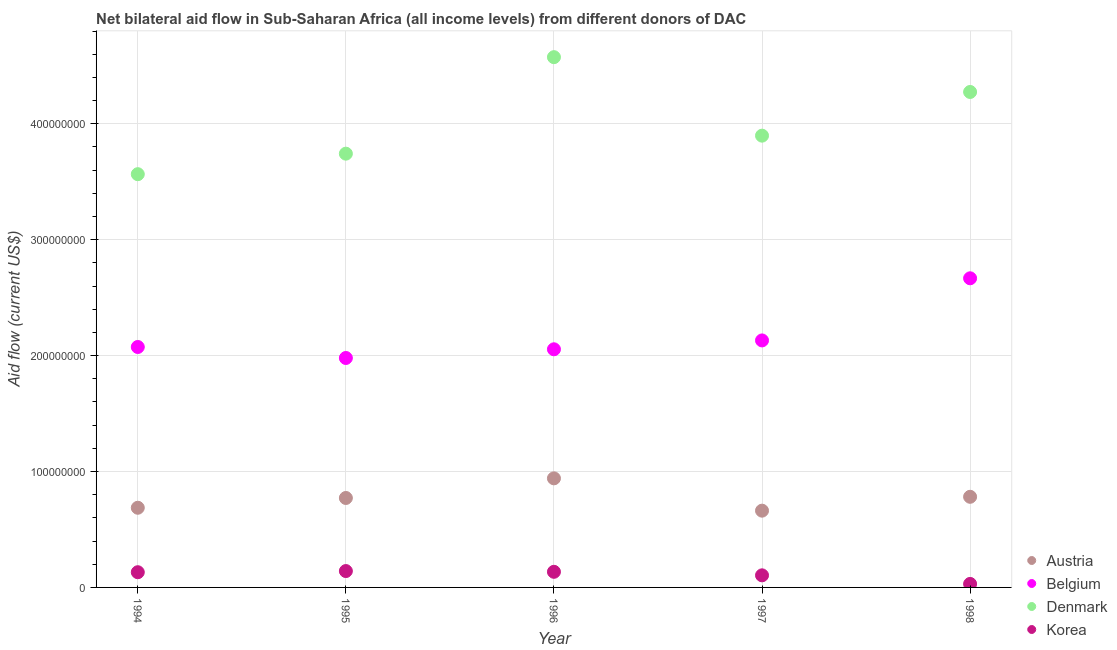How many different coloured dotlines are there?
Provide a short and direct response. 4. What is the amount of aid given by korea in 1998?
Your response must be concise. 3.02e+06. Across all years, what is the maximum amount of aid given by austria?
Ensure brevity in your answer.  9.41e+07. Across all years, what is the minimum amount of aid given by austria?
Keep it short and to the point. 6.62e+07. What is the total amount of aid given by belgium in the graph?
Give a very brief answer. 1.09e+09. What is the difference between the amount of aid given by korea in 1995 and that in 1996?
Your answer should be compact. 6.50e+05. What is the difference between the amount of aid given by denmark in 1997 and the amount of aid given by austria in 1998?
Offer a terse response. 3.12e+08. What is the average amount of aid given by belgium per year?
Give a very brief answer. 2.18e+08. In the year 1994, what is the difference between the amount of aid given by belgium and amount of aid given by austria?
Your answer should be compact. 1.39e+08. In how many years, is the amount of aid given by belgium greater than 460000000 US$?
Your response must be concise. 0. What is the ratio of the amount of aid given by austria in 1996 to that in 1998?
Give a very brief answer. 1.2. Is the difference between the amount of aid given by denmark in 1994 and 1995 greater than the difference between the amount of aid given by belgium in 1994 and 1995?
Provide a succinct answer. No. What is the difference between the highest and the second highest amount of aid given by korea?
Keep it short and to the point. 6.50e+05. What is the difference between the highest and the lowest amount of aid given by korea?
Provide a succinct answer. 1.11e+07. Is the sum of the amount of aid given by austria in 1995 and 1997 greater than the maximum amount of aid given by denmark across all years?
Offer a very short reply. No. Is it the case that in every year, the sum of the amount of aid given by denmark and amount of aid given by korea is greater than the sum of amount of aid given by belgium and amount of aid given by austria?
Your response must be concise. No. Is the amount of aid given by austria strictly greater than the amount of aid given by denmark over the years?
Make the answer very short. No. Is the amount of aid given by belgium strictly less than the amount of aid given by denmark over the years?
Offer a very short reply. Yes. How many dotlines are there?
Your response must be concise. 4. Are the values on the major ticks of Y-axis written in scientific E-notation?
Your answer should be very brief. No. Does the graph contain any zero values?
Give a very brief answer. No. Does the graph contain grids?
Your response must be concise. Yes. What is the title of the graph?
Your answer should be compact. Net bilateral aid flow in Sub-Saharan Africa (all income levels) from different donors of DAC. What is the label or title of the X-axis?
Make the answer very short. Year. What is the Aid flow (current US$) in Austria in 1994?
Provide a short and direct response. 6.87e+07. What is the Aid flow (current US$) in Belgium in 1994?
Offer a very short reply. 2.07e+08. What is the Aid flow (current US$) in Denmark in 1994?
Provide a succinct answer. 3.56e+08. What is the Aid flow (current US$) in Korea in 1994?
Offer a terse response. 1.31e+07. What is the Aid flow (current US$) in Austria in 1995?
Keep it short and to the point. 7.72e+07. What is the Aid flow (current US$) of Belgium in 1995?
Make the answer very short. 1.98e+08. What is the Aid flow (current US$) of Denmark in 1995?
Ensure brevity in your answer.  3.74e+08. What is the Aid flow (current US$) in Korea in 1995?
Give a very brief answer. 1.41e+07. What is the Aid flow (current US$) of Austria in 1996?
Offer a terse response. 9.41e+07. What is the Aid flow (current US$) in Belgium in 1996?
Offer a very short reply. 2.05e+08. What is the Aid flow (current US$) of Denmark in 1996?
Provide a succinct answer. 4.57e+08. What is the Aid flow (current US$) of Korea in 1996?
Make the answer very short. 1.35e+07. What is the Aid flow (current US$) of Austria in 1997?
Your response must be concise. 6.62e+07. What is the Aid flow (current US$) of Belgium in 1997?
Your response must be concise. 2.13e+08. What is the Aid flow (current US$) in Denmark in 1997?
Make the answer very short. 3.90e+08. What is the Aid flow (current US$) of Korea in 1997?
Your answer should be very brief. 1.04e+07. What is the Aid flow (current US$) of Austria in 1998?
Your response must be concise. 7.82e+07. What is the Aid flow (current US$) of Belgium in 1998?
Your answer should be very brief. 2.67e+08. What is the Aid flow (current US$) of Denmark in 1998?
Ensure brevity in your answer.  4.27e+08. What is the Aid flow (current US$) in Korea in 1998?
Provide a succinct answer. 3.02e+06. Across all years, what is the maximum Aid flow (current US$) in Austria?
Your response must be concise. 9.41e+07. Across all years, what is the maximum Aid flow (current US$) in Belgium?
Give a very brief answer. 2.67e+08. Across all years, what is the maximum Aid flow (current US$) in Denmark?
Your response must be concise. 4.57e+08. Across all years, what is the maximum Aid flow (current US$) in Korea?
Your answer should be very brief. 1.41e+07. Across all years, what is the minimum Aid flow (current US$) in Austria?
Ensure brevity in your answer.  6.62e+07. Across all years, what is the minimum Aid flow (current US$) in Belgium?
Provide a short and direct response. 1.98e+08. Across all years, what is the minimum Aid flow (current US$) of Denmark?
Provide a short and direct response. 3.56e+08. Across all years, what is the minimum Aid flow (current US$) in Korea?
Provide a short and direct response. 3.02e+06. What is the total Aid flow (current US$) in Austria in the graph?
Provide a short and direct response. 3.84e+08. What is the total Aid flow (current US$) of Belgium in the graph?
Your response must be concise. 1.09e+09. What is the total Aid flow (current US$) of Denmark in the graph?
Provide a short and direct response. 2.01e+09. What is the total Aid flow (current US$) of Korea in the graph?
Provide a succinct answer. 5.42e+07. What is the difference between the Aid flow (current US$) of Austria in 1994 and that in 1995?
Offer a very short reply. -8.43e+06. What is the difference between the Aid flow (current US$) in Belgium in 1994 and that in 1995?
Your answer should be compact. 9.49e+06. What is the difference between the Aid flow (current US$) of Denmark in 1994 and that in 1995?
Provide a short and direct response. -1.77e+07. What is the difference between the Aid flow (current US$) of Korea in 1994 and that in 1995?
Your answer should be very brief. -1.00e+06. What is the difference between the Aid flow (current US$) of Austria in 1994 and that in 1996?
Your answer should be very brief. -2.54e+07. What is the difference between the Aid flow (current US$) in Belgium in 1994 and that in 1996?
Keep it short and to the point. 1.99e+06. What is the difference between the Aid flow (current US$) of Denmark in 1994 and that in 1996?
Your response must be concise. -1.01e+08. What is the difference between the Aid flow (current US$) in Korea in 1994 and that in 1996?
Give a very brief answer. -3.50e+05. What is the difference between the Aid flow (current US$) in Austria in 1994 and that in 1997?
Offer a terse response. 2.51e+06. What is the difference between the Aid flow (current US$) of Belgium in 1994 and that in 1997?
Offer a very short reply. -5.66e+06. What is the difference between the Aid flow (current US$) in Denmark in 1994 and that in 1997?
Your answer should be very brief. -3.32e+07. What is the difference between the Aid flow (current US$) of Korea in 1994 and that in 1997?
Your answer should be very brief. 2.69e+06. What is the difference between the Aid flow (current US$) of Austria in 1994 and that in 1998?
Ensure brevity in your answer.  -9.45e+06. What is the difference between the Aid flow (current US$) of Belgium in 1994 and that in 1998?
Provide a short and direct response. -5.93e+07. What is the difference between the Aid flow (current US$) in Denmark in 1994 and that in 1998?
Give a very brief answer. -7.09e+07. What is the difference between the Aid flow (current US$) of Korea in 1994 and that in 1998?
Provide a short and direct response. 1.01e+07. What is the difference between the Aid flow (current US$) of Austria in 1995 and that in 1996?
Your answer should be compact. -1.69e+07. What is the difference between the Aid flow (current US$) in Belgium in 1995 and that in 1996?
Provide a short and direct response. -7.50e+06. What is the difference between the Aid flow (current US$) of Denmark in 1995 and that in 1996?
Give a very brief answer. -8.32e+07. What is the difference between the Aid flow (current US$) in Korea in 1995 and that in 1996?
Your answer should be very brief. 6.50e+05. What is the difference between the Aid flow (current US$) in Austria in 1995 and that in 1997?
Provide a short and direct response. 1.09e+07. What is the difference between the Aid flow (current US$) in Belgium in 1995 and that in 1997?
Keep it short and to the point. -1.52e+07. What is the difference between the Aid flow (current US$) in Denmark in 1995 and that in 1997?
Make the answer very short. -1.55e+07. What is the difference between the Aid flow (current US$) of Korea in 1995 and that in 1997?
Ensure brevity in your answer.  3.69e+06. What is the difference between the Aid flow (current US$) in Austria in 1995 and that in 1998?
Give a very brief answer. -1.02e+06. What is the difference between the Aid flow (current US$) of Belgium in 1995 and that in 1998?
Your answer should be compact. -6.88e+07. What is the difference between the Aid flow (current US$) in Denmark in 1995 and that in 1998?
Your response must be concise. -5.32e+07. What is the difference between the Aid flow (current US$) in Korea in 1995 and that in 1998?
Your response must be concise. 1.11e+07. What is the difference between the Aid flow (current US$) in Austria in 1996 and that in 1997?
Provide a succinct answer. 2.79e+07. What is the difference between the Aid flow (current US$) in Belgium in 1996 and that in 1997?
Offer a very short reply. -7.65e+06. What is the difference between the Aid flow (current US$) in Denmark in 1996 and that in 1997?
Make the answer very short. 6.77e+07. What is the difference between the Aid flow (current US$) in Korea in 1996 and that in 1997?
Your answer should be very brief. 3.04e+06. What is the difference between the Aid flow (current US$) of Austria in 1996 and that in 1998?
Provide a short and direct response. 1.59e+07. What is the difference between the Aid flow (current US$) of Belgium in 1996 and that in 1998?
Provide a short and direct response. -6.12e+07. What is the difference between the Aid flow (current US$) of Denmark in 1996 and that in 1998?
Provide a short and direct response. 3.00e+07. What is the difference between the Aid flow (current US$) of Korea in 1996 and that in 1998?
Provide a succinct answer. 1.04e+07. What is the difference between the Aid flow (current US$) of Austria in 1997 and that in 1998?
Your answer should be very brief. -1.20e+07. What is the difference between the Aid flow (current US$) of Belgium in 1997 and that in 1998?
Your response must be concise. -5.36e+07. What is the difference between the Aid flow (current US$) of Denmark in 1997 and that in 1998?
Your answer should be very brief. -3.77e+07. What is the difference between the Aid flow (current US$) of Korea in 1997 and that in 1998?
Offer a very short reply. 7.41e+06. What is the difference between the Aid flow (current US$) of Austria in 1994 and the Aid flow (current US$) of Belgium in 1995?
Make the answer very short. -1.29e+08. What is the difference between the Aid flow (current US$) in Austria in 1994 and the Aid flow (current US$) in Denmark in 1995?
Your response must be concise. -3.05e+08. What is the difference between the Aid flow (current US$) of Austria in 1994 and the Aid flow (current US$) of Korea in 1995?
Keep it short and to the point. 5.46e+07. What is the difference between the Aid flow (current US$) in Belgium in 1994 and the Aid flow (current US$) in Denmark in 1995?
Offer a terse response. -1.67e+08. What is the difference between the Aid flow (current US$) in Belgium in 1994 and the Aid flow (current US$) in Korea in 1995?
Ensure brevity in your answer.  1.93e+08. What is the difference between the Aid flow (current US$) of Denmark in 1994 and the Aid flow (current US$) of Korea in 1995?
Provide a succinct answer. 3.42e+08. What is the difference between the Aid flow (current US$) of Austria in 1994 and the Aid flow (current US$) of Belgium in 1996?
Provide a succinct answer. -1.37e+08. What is the difference between the Aid flow (current US$) in Austria in 1994 and the Aid flow (current US$) in Denmark in 1996?
Give a very brief answer. -3.89e+08. What is the difference between the Aid flow (current US$) of Austria in 1994 and the Aid flow (current US$) of Korea in 1996?
Your answer should be very brief. 5.53e+07. What is the difference between the Aid flow (current US$) in Belgium in 1994 and the Aid flow (current US$) in Denmark in 1996?
Provide a short and direct response. -2.50e+08. What is the difference between the Aid flow (current US$) of Belgium in 1994 and the Aid flow (current US$) of Korea in 1996?
Provide a short and direct response. 1.94e+08. What is the difference between the Aid flow (current US$) of Denmark in 1994 and the Aid flow (current US$) of Korea in 1996?
Provide a succinct answer. 3.43e+08. What is the difference between the Aid flow (current US$) of Austria in 1994 and the Aid flow (current US$) of Belgium in 1997?
Give a very brief answer. -1.44e+08. What is the difference between the Aid flow (current US$) of Austria in 1994 and the Aid flow (current US$) of Denmark in 1997?
Keep it short and to the point. -3.21e+08. What is the difference between the Aid flow (current US$) in Austria in 1994 and the Aid flow (current US$) in Korea in 1997?
Give a very brief answer. 5.83e+07. What is the difference between the Aid flow (current US$) of Belgium in 1994 and the Aid flow (current US$) of Denmark in 1997?
Your response must be concise. -1.82e+08. What is the difference between the Aid flow (current US$) of Belgium in 1994 and the Aid flow (current US$) of Korea in 1997?
Make the answer very short. 1.97e+08. What is the difference between the Aid flow (current US$) in Denmark in 1994 and the Aid flow (current US$) in Korea in 1997?
Ensure brevity in your answer.  3.46e+08. What is the difference between the Aid flow (current US$) of Austria in 1994 and the Aid flow (current US$) of Belgium in 1998?
Your answer should be very brief. -1.98e+08. What is the difference between the Aid flow (current US$) in Austria in 1994 and the Aid flow (current US$) in Denmark in 1998?
Your response must be concise. -3.59e+08. What is the difference between the Aid flow (current US$) of Austria in 1994 and the Aid flow (current US$) of Korea in 1998?
Your response must be concise. 6.57e+07. What is the difference between the Aid flow (current US$) of Belgium in 1994 and the Aid flow (current US$) of Denmark in 1998?
Your answer should be very brief. -2.20e+08. What is the difference between the Aid flow (current US$) of Belgium in 1994 and the Aid flow (current US$) of Korea in 1998?
Ensure brevity in your answer.  2.04e+08. What is the difference between the Aid flow (current US$) of Denmark in 1994 and the Aid flow (current US$) of Korea in 1998?
Offer a terse response. 3.53e+08. What is the difference between the Aid flow (current US$) in Austria in 1995 and the Aid flow (current US$) in Belgium in 1996?
Make the answer very short. -1.28e+08. What is the difference between the Aid flow (current US$) of Austria in 1995 and the Aid flow (current US$) of Denmark in 1996?
Give a very brief answer. -3.80e+08. What is the difference between the Aid flow (current US$) of Austria in 1995 and the Aid flow (current US$) of Korea in 1996?
Your answer should be compact. 6.37e+07. What is the difference between the Aid flow (current US$) in Belgium in 1995 and the Aid flow (current US$) in Denmark in 1996?
Provide a short and direct response. -2.60e+08. What is the difference between the Aid flow (current US$) in Belgium in 1995 and the Aid flow (current US$) in Korea in 1996?
Your response must be concise. 1.84e+08. What is the difference between the Aid flow (current US$) in Denmark in 1995 and the Aid flow (current US$) in Korea in 1996?
Your answer should be very brief. 3.61e+08. What is the difference between the Aid flow (current US$) of Austria in 1995 and the Aid flow (current US$) of Belgium in 1997?
Provide a short and direct response. -1.36e+08. What is the difference between the Aid flow (current US$) of Austria in 1995 and the Aid flow (current US$) of Denmark in 1997?
Keep it short and to the point. -3.13e+08. What is the difference between the Aid flow (current US$) of Austria in 1995 and the Aid flow (current US$) of Korea in 1997?
Offer a terse response. 6.67e+07. What is the difference between the Aid flow (current US$) in Belgium in 1995 and the Aid flow (current US$) in Denmark in 1997?
Offer a very short reply. -1.92e+08. What is the difference between the Aid flow (current US$) in Belgium in 1995 and the Aid flow (current US$) in Korea in 1997?
Give a very brief answer. 1.88e+08. What is the difference between the Aid flow (current US$) of Denmark in 1995 and the Aid flow (current US$) of Korea in 1997?
Provide a short and direct response. 3.64e+08. What is the difference between the Aid flow (current US$) of Austria in 1995 and the Aid flow (current US$) of Belgium in 1998?
Provide a short and direct response. -1.90e+08. What is the difference between the Aid flow (current US$) of Austria in 1995 and the Aid flow (current US$) of Denmark in 1998?
Provide a succinct answer. -3.50e+08. What is the difference between the Aid flow (current US$) in Austria in 1995 and the Aid flow (current US$) in Korea in 1998?
Make the answer very short. 7.41e+07. What is the difference between the Aid flow (current US$) of Belgium in 1995 and the Aid flow (current US$) of Denmark in 1998?
Your response must be concise. -2.29e+08. What is the difference between the Aid flow (current US$) of Belgium in 1995 and the Aid flow (current US$) of Korea in 1998?
Provide a succinct answer. 1.95e+08. What is the difference between the Aid flow (current US$) of Denmark in 1995 and the Aid flow (current US$) of Korea in 1998?
Give a very brief answer. 3.71e+08. What is the difference between the Aid flow (current US$) in Austria in 1996 and the Aid flow (current US$) in Belgium in 1997?
Make the answer very short. -1.19e+08. What is the difference between the Aid flow (current US$) in Austria in 1996 and the Aid flow (current US$) in Denmark in 1997?
Offer a terse response. -2.96e+08. What is the difference between the Aid flow (current US$) of Austria in 1996 and the Aid flow (current US$) of Korea in 1997?
Your answer should be very brief. 8.37e+07. What is the difference between the Aid flow (current US$) in Belgium in 1996 and the Aid flow (current US$) in Denmark in 1997?
Your answer should be compact. -1.84e+08. What is the difference between the Aid flow (current US$) of Belgium in 1996 and the Aid flow (current US$) of Korea in 1997?
Your answer should be very brief. 1.95e+08. What is the difference between the Aid flow (current US$) in Denmark in 1996 and the Aid flow (current US$) in Korea in 1997?
Offer a very short reply. 4.47e+08. What is the difference between the Aid flow (current US$) in Austria in 1996 and the Aid flow (current US$) in Belgium in 1998?
Your answer should be compact. -1.73e+08. What is the difference between the Aid flow (current US$) in Austria in 1996 and the Aid flow (current US$) in Denmark in 1998?
Your response must be concise. -3.33e+08. What is the difference between the Aid flow (current US$) in Austria in 1996 and the Aid flow (current US$) in Korea in 1998?
Your answer should be compact. 9.11e+07. What is the difference between the Aid flow (current US$) of Belgium in 1996 and the Aid flow (current US$) of Denmark in 1998?
Your answer should be compact. -2.22e+08. What is the difference between the Aid flow (current US$) of Belgium in 1996 and the Aid flow (current US$) of Korea in 1998?
Keep it short and to the point. 2.02e+08. What is the difference between the Aid flow (current US$) in Denmark in 1996 and the Aid flow (current US$) in Korea in 1998?
Ensure brevity in your answer.  4.54e+08. What is the difference between the Aid flow (current US$) in Austria in 1997 and the Aid flow (current US$) in Belgium in 1998?
Ensure brevity in your answer.  -2.00e+08. What is the difference between the Aid flow (current US$) in Austria in 1997 and the Aid flow (current US$) in Denmark in 1998?
Provide a succinct answer. -3.61e+08. What is the difference between the Aid flow (current US$) in Austria in 1997 and the Aid flow (current US$) in Korea in 1998?
Offer a very short reply. 6.32e+07. What is the difference between the Aid flow (current US$) of Belgium in 1997 and the Aid flow (current US$) of Denmark in 1998?
Your answer should be compact. -2.14e+08. What is the difference between the Aid flow (current US$) in Belgium in 1997 and the Aid flow (current US$) in Korea in 1998?
Your answer should be compact. 2.10e+08. What is the difference between the Aid flow (current US$) in Denmark in 1997 and the Aid flow (current US$) in Korea in 1998?
Ensure brevity in your answer.  3.87e+08. What is the average Aid flow (current US$) in Austria per year?
Make the answer very short. 7.69e+07. What is the average Aid flow (current US$) of Belgium per year?
Your answer should be very brief. 2.18e+08. What is the average Aid flow (current US$) of Denmark per year?
Your answer should be compact. 4.01e+08. What is the average Aid flow (current US$) in Korea per year?
Offer a terse response. 1.08e+07. In the year 1994, what is the difference between the Aid flow (current US$) of Austria and Aid flow (current US$) of Belgium?
Ensure brevity in your answer.  -1.39e+08. In the year 1994, what is the difference between the Aid flow (current US$) of Austria and Aid flow (current US$) of Denmark?
Your response must be concise. -2.88e+08. In the year 1994, what is the difference between the Aid flow (current US$) of Austria and Aid flow (current US$) of Korea?
Provide a succinct answer. 5.56e+07. In the year 1994, what is the difference between the Aid flow (current US$) of Belgium and Aid flow (current US$) of Denmark?
Keep it short and to the point. -1.49e+08. In the year 1994, what is the difference between the Aid flow (current US$) in Belgium and Aid flow (current US$) in Korea?
Give a very brief answer. 1.94e+08. In the year 1994, what is the difference between the Aid flow (current US$) in Denmark and Aid flow (current US$) in Korea?
Make the answer very short. 3.43e+08. In the year 1995, what is the difference between the Aid flow (current US$) in Austria and Aid flow (current US$) in Belgium?
Keep it short and to the point. -1.21e+08. In the year 1995, what is the difference between the Aid flow (current US$) in Austria and Aid flow (current US$) in Denmark?
Provide a short and direct response. -2.97e+08. In the year 1995, what is the difference between the Aid flow (current US$) of Austria and Aid flow (current US$) of Korea?
Your response must be concise. 6.30e+07. In the year 1995, what is the difference between the Aid flow (current US$) in Belgium and Aid flow (current US$) in Denmark?
Make the answer very short. -1.76e+08. In the year 1995, what is the difference between the Aid flow (current US$) in Belgium and Aid flow (current US$) in Korea?
Give a very brief answer. 1.84e+08. In the year 1995, what is the difference between the Aid flow (current US$) of Denmark and Aid flow (current US$) of Korea?
Give a very brief answer. 3.60e+08. In the year 1996, what is the difference between the Aid flow (current US$) in Austria and Aid flow (current US$) in Belgium?
Keep it short and to the point. -1.11e+08. In the year 1996, what is the difference between the Aid flow (current US$) in Austria and Aid flow (current US$) in Denmark?
Keep it short and to the point. -3.63e+08. In the year 1996, what is the difference between the Aid flow (current US$) in Austria and Aid flow (current US$) in Korea?
Offer a terse response. 8.06e+07. In the year 1996, what is the difference between the Aid flow (current US$) in Belgium and Aid flow (current US$) in Denmark?
Ensure brevity in your answer.  -2.52e+08. In the year 1996, what is the difference between the Aid flow (current US$) in Belgium and Aid flow (current US$) in Korea?
Your answer should be compact. 1.92e+08. In the year 1996, what is the difference between the Aid flow (current US$) in Denmark and Aid flow (current US$) in Korea?
Make the answer very short. 4.44e+08. In the year 1997, what is the difference between the Aid flow (current US$) in Austria and Aid flow (current US$) in Belgium?
Offer a terse response. -1.47e+08. In the year 1997, what is the difference between the Aid flow (current US$) in Austria and Aid flow (current US$) in Denmark?
Keep it short and to the point. -3.24e+08. In the year 1997, what is the difference between the Aid flow (current US$) in Austria and Aid flow (current US$) in Korea?
Your answer should be very brief. 5.58e+07. In the year 1997, what is the difference between the Aid flow (current US$) of Belgium and Aid flow (current US$) of Denmark?
Keep it short and to the point. -1.77e+08. In the year 1997, what is the difference between the Aid flow (current US$) of Belgium and Aid flow (current US$) of Korea?
Give a very brief answer. 2.03e+08. In the year 1997, what is the difference between the Aid flow (current US$) in Denmark and Aid flow (current US$) in Korea?
Your response must be concise. 3.79e+08. In the year 1998, what is the difference between the Aid flow (current US$) in Austria and Aid flow (current US$) in Belgium?
Your answer should be compact. -1.88e+08. In the year 1998, what is the difference between the Aid flow (current US$) of Austria and Aid flow (current US$) of Denmark?
Give a very brief answer. -3.49e+08. In the year 1998, what is the difference between the Aid flow (current US$) in Austria and Aid flow (current US$) in Korea?
Your answer should be compact. 7.52e+07. In the year 1998, what is the difference between the Aid flow (current US$) in Belgium and Aid flow (current US$) in Denmark?
Your answer should be compact. -1.61e+08. In the year 1998, what is the difference between the Aid flow (current US$) of Belgium and Aid flow (current US$) of Korea?
Provide a short and direct response. 2.64e+08. In the year 1998, what is the difference between the Aid flow (current US$) in Denmark and Aid flow (current US$) in Korea?
Offer a very short reply. 4.24e+08. What is the ratio of the Aid flow (current US$) of Austria in 1994 to that in 1995?
Provide a succinct answer. 0.89. What is the ratio of the Aid flow (current US$) in Belgium in 1994 to that in 1995?
Make the answer very short. 1.05. What is the ratio of the Aid flow (current US$) of Denmark in 1994 to that in 1995?
Ensure brevity in your answer.  0.95. What is the ratio of the Aid flow (current US$) of Korea in 1994 to that in 1995?
Offer a very short reply. 0.93. What is the ratio of the Aid flow (current US$) in Austria in 1994 to that in 1996?
Give a very brief answer. 0.73. What is the ratio of the Aid flow (current US$) of Belgium in 1994 to that in 1996?
Your answer should be compact. 1.01. What is the ratio of the Aid flow (current US$) in Denmark in 1994 to that in 1996?
Keep it short and to the point. 0.78. What is the ratio of the Aid flow (current US$) in Austria in 1994 to that in 1997?
Provide a succinct answer. 1.04. What is the ratio of the Aid flow (current US$) in Belgium in 1994 to that in 1997?
Provide a succinct answer. 0.97. What is the ratio of the Aid flow (current US$) in Denmark in 1994 to that in 1997?
Keep it short and to the point. 0.91. What is the ratio of the Aid flow (current US$) in Korea in 1994 to that in 1997?
Provide a succinct answer. 1.26. What is the ratio of the Aid flow (current US$) in Austria in 1994 to that in 1998?
Provide a short and direct response. 0.88. What is the ratio of the Aid flow (current US$) in Belgium in 1994 to that in 1998?
Provide a succinct answer. 0.78. What is the ratio of the Aid flow (current US$) in Denmark in 1994 to that in 1998?
Ensure brevity in your answer.  0.83. What is the ratio of the Aid flow (current US$) of Korea in 1994 to that in 1998?
Provide a short and direct response. 4.34. What is the ratio of the Aid flow (current US$) in Austria in 1995 to that in 1996?
Your answer should be compact. 0.82. What is the ratio of the Aid flow (current US$) of Belgium in 1995 to that in 1996?
Keep it short and to the point. 0.96. What is the ratio of the Aid flow (current US$) of Denmark in 1995 to that in 1996?
Offer a very short reply. 0.82. What is the ratio of the Aid flow (current US$) of Korea in 1995 to that in 1996?
Provide a short and direct response. 1.05. What is the ratio of the Aid flow (current US$) in Austria in 1995 to that in 1997?
Make the answer very short. 1.17. What is the ratio of the Aid flow (current US$) in Belgium in 1995 to that in 1997?
Offer a very short reply. 0.93. What is the ratio of the Aid flow (current US$) of Denmark in 1995 to that in 1997?
Offer a very short reply. 0.96. What is the ratio of the Aid flow (current US$) of Korea in 1995 to that in 1997?
Provide a short and direct response. 1.35. What is the ratio of the Aid flow (current US$) of Austria in 1995 to that in 1998?
Ensure brevity in your answer.  0.99. What is the ratio of the Aid flow (current US$) in Belgium in 1995 to that in 1998?
Keep it short and to the point. 0.74. What is the ratio of the Aid flow (current US$) of Denmark in 1995 to that in 1998?
Your answer should be compact. 0.88. What is the ratio of the Aid flow (current US$) in Korea in 1995 to that in 1998?
Your response must be concise. 4.68. What is the ratio of the Aid flow (current US$) in Austria in 1996 to that in 1997?
Keep it short and to the point. 1.42. What is the ratio of the Aid flow (current US$) of Belgium in 1996 to that in 1997?
Provide a succinct answer. 0.96. What is the ratio of the Aid flow (current US$) of Denmark in 1996 to that in 1997?
Your response must be concise. 1.17. What is the ratio of the Aid flow (current US$) of Korea in 1996 to that in 1997?
Offer a terse response. 1.29. What is the ratio of the Aid flow (current US$) of Austria in 1996 to that in 1998?
Your response must be concise. 1.2. What is the ratio of the Aid flow (current US$) of Belgium in 1996 to that in 1998?
Provide a succinct answer. 0.77. What is the ratio of the Aid flow (current US$) in Denmark in 1996 to that in 1998?
Provide a short and direct response. 1.07. What is the ratio of the Aid flow (current US$) in Korea in 1996 to that in 1998?
Give a very brief answer. 4.46. What is the ratio of the Aid flow (current US$) in Austria in 1997 to that in 1998?
Keep it short and to the point. 0.85. What is the ratio of the Aid flow (current US$) of Belgium in 1997 to that in 1998?
Give a very brief answer. 0.8. What is the ratio of the Aid flow (current US$) of Denmark in 1997 to that in 1998?
Ensure brevity in your answer.  0.91. What is the ratio of the Aid flow (current US$) of Korea in 1997 to that in 1998?
Provide a succinct answer. 3.45. What is the difference between the highest and the second highest Aid flow (current US$) of Austria?
Give a very brief answer. 1.59e+07. What is the difference between the highest and the second highest Aid flow (current US$) of Belgium?
Your answer should be compact. 5.36e+07. What is the difference between the highest and the second highest Aid flow (current US$) of Denmark?
Ensure brevity in your answer.  3.00e+07. What is the difference between the highest and the second highest Aid flow (current US$) in Korea?
Ensure brevity in your answer.  6.50e+05. What is the difference between the highest and the lowest Aid flow (current US$) of Austria?
Keep it short and to the point. 2.79e+07. What is the difference between the highest and the lowest Aid flow (current US$) in Belgium?
Your response must be concise. 6.88e+07. What is the difference between the highest and the lowest Aid flow (current US$) in Denmark?
Your answer should be very brief. 1.01e+08. What is the difference between the highest and the lowest Aid flow (current US$) in Korea?
Ensure brevity in your answer.  1.11e+07. 